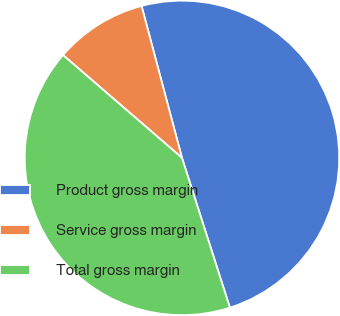Convert chart. <chart><loc_0><loc_0><loc_500><loc_500><pie_chart><fcel>Product gross margin<fcel>Service gross margin<fcel>Total gross margin<nl><fcel>49.21%<fcel>9.52%<fcel>41.27%<nl></chart> 